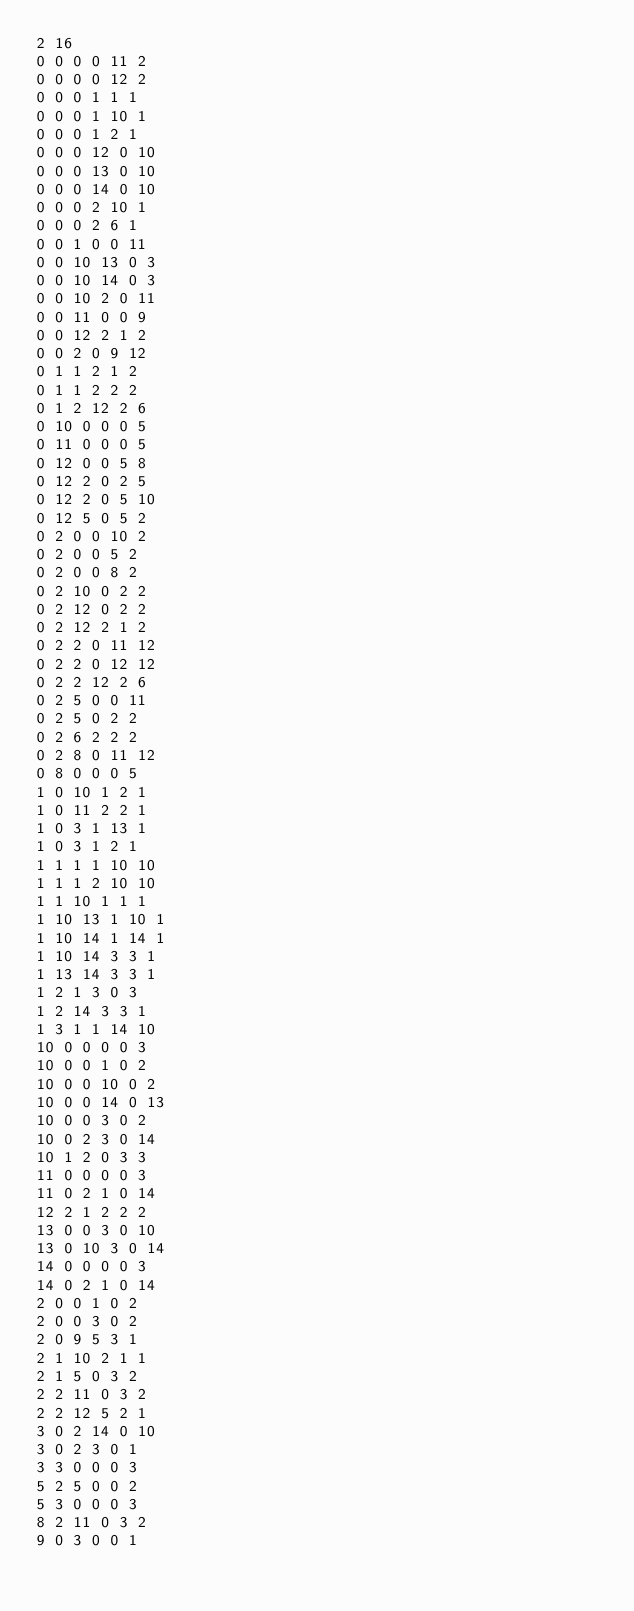Convert code to text. <code><loc_0><loc_0><loc_500><loc_500><_SQL_>2 16
0 0 0 0 11 2
0 0 0 0 12 2
0 0 0 1 1 1
0 0 0 1 10 1
0 0 0 1 2 1
0 0 0 12 0 10
0 0 0 13 0 10
0 0 0 14 0 10
0 0 0 2 10 1
0 0 0 2 6 1
0 0 1 0 0 11
0 0 10 13 0 3
0 0 10 14 0 3
0 0 10 2 0 11
0 0 11 0 0 9
0 0 12 2 1 2
0 0 2 0 9 12
0 1 1 2 1 2
0 1 1 2 2 2
0 1 2 12 2 6
0 10 0 0 0 5
0 11 0 0 0 5
0 12 0 0 5 8
0 12 2 0 2 5
0 12 2 0 5 10
0 12 5 0 5 2
0 2 0 0 10 2
0 2 0 0 5 2
0 2 0 0 8 2
0 2 10 0 2 2
0 2 12 0 2 2
0 2 12 2 1 2
0 2 2 0 11 12
0 2 2 0 12 12
0 2 2 12 2 6
0 2 5 0 0 11
0 2 5 0 2 2
0 2 6 2 2 2
0 2 8 0 11 12
0 8 0 0 0 5
1 0 10 1 2 1
1 0 11 2 2 1
1 0 3 1 13 1
1 0 3 1 2 1
1 1 1 1 10 10
1 1 1 2 10 10
1 1 10 1 1 1
1 10 13 1 10 1
1 10 14 1 14 1
1 10 14 3 3 1
1 13 14 3 3 1
1 2 1 3 0 3
1 2 14 3 3 1
1 3 1 1 14 10
10 0 0 0 0 3
10 0 0 1 0 2
10 0 0 10 0 2
10 0 0 14 0 13
10 0 0 3 0 2
10 0 2 3 0 14
10 1 2 0 3 3
11 0 0 0 0 3
11 0 2 1 0 14
12 2 1 2 2 2
13 0 0 3 0 10
13 0 10 3 0 14
14 0 0 0 0 3
14 0 2 1 0 14
2 0 0 1 0 2
2 0 0 3 0 2
2 0 9 5 3 1
2 1 10 2 1 1
2 1 5 0 3 2
2 2 11 0 3 2
2 2 12 5 2 1
3 0 2 14 0 10
3 0 2 3 0 1
3 3 0 0 0 3
5 2 5 0 0 2
5 3 0 0 0 3
8 2 11 0 3 2
9 0 3 0 0 1
</code> 